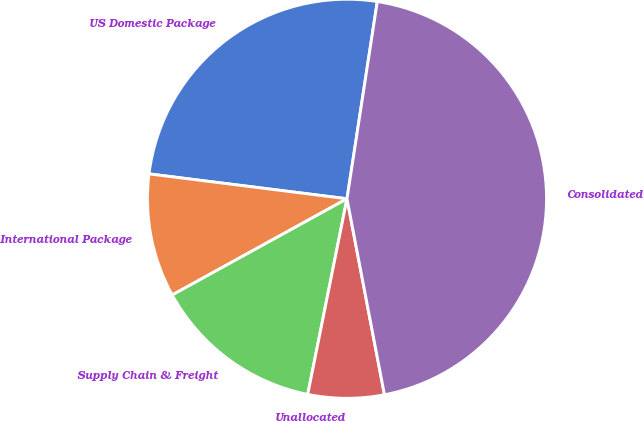Convert chart. <chart><loc_0><loc_0><loc_500><loc_500><pie_chart><fcel>US Domestic Package<fcel>International Package<fcel>Supply Chain & Freight<fcel>Unallocated<fcel>Consolidated<nl><fcel>25.44%<fcel>10.0%<fcel>13.84%<fcel>6.16%<fcel>44.57%<nl></chart> 